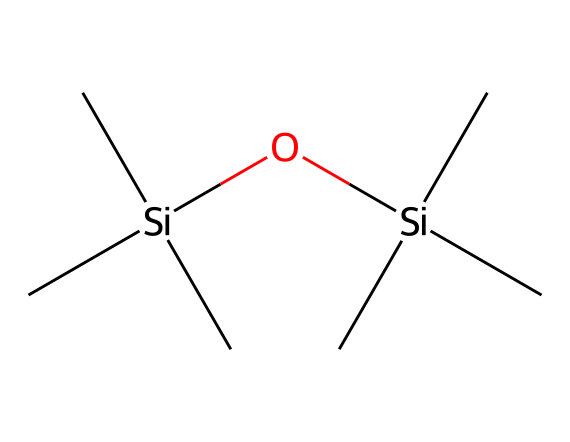What is the molecular formula of this compound? By analyzing the SMILES representation, we can identify each type of atom present. The structure contains 8 carbon (C) atoms and 2 silicon (Si) atoms, along with 1 oxygen (O) atom. Therefore, counting them gives us the formula: C8H24O2Si2.
Answer: C8H24O2Si2 How many silicon atoms are in the structure? In the provided SMILES representation, the two distinct instances of "Si" indicate the presence of two silicon atoms in the compound.
Answer: 2 How many carbon atoms are in the molecule? The SMILES notation includes eight "C" symbols, each representing a carbon atom. Counting these gives us a total of eight carbon atoms present in the molecule.
Answer: 8 Is this compound hydrophobic or hydrophilic? The presence of silicone (Si) and alkyl groups (C) usually contributes to hydrophobic properties, making this compound hydrophobic.
Answer: hydrophobic What type of silicon-based chemical is this? This compound is a dimethylsiloxane, characterized by the alternating silicon and oxygen atoms in its structure, along with its methyl (C) groups.
Answer: dimethylsiloxane What is the common use of this compound? Hexamethyldisiloxane is commonly used in hair care products and cosmetics, providing smooth texture and improving shine.
Answer: hair care products 